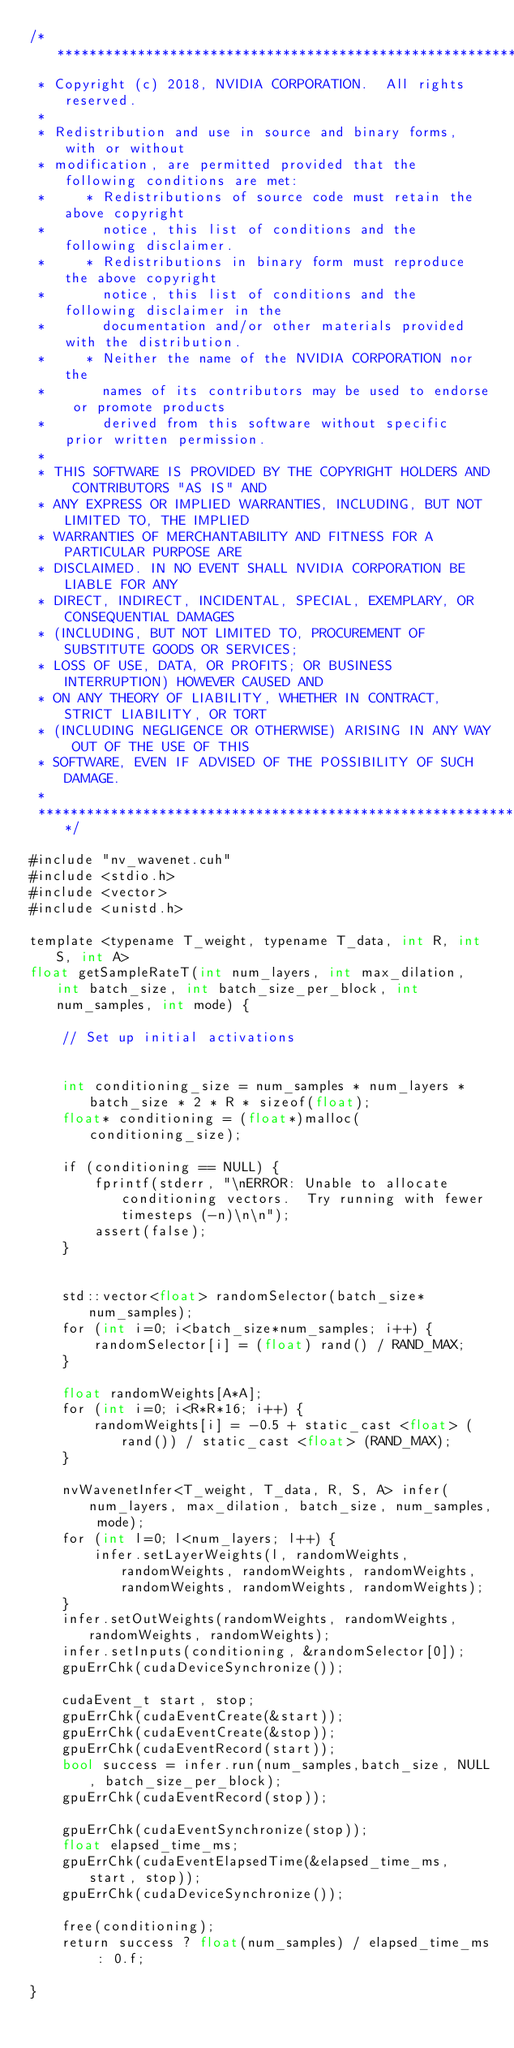<code> <loc_0><loc_0><loc_500><loc_500><_Cuda_>/******************************************************************************
 * Copyright (c) 2018, NVIDIA CORPORATION.  All rights reserved.
 *
 * Redistribution and use in source and binary forms, with or without
 * modification, are permitted provided that the following conditions are met:
 *     * Redistributions of source code must retain the above copyright
 *       notice, this list of conditions and the following disclaimer.
 *     * Redistributions in binary form must reproduce the above copyright
 *       notice, this list of conditions and the following disclaimer in the
 *       documentation and/or other materials provided with the distribution.
 *     * Neither the name of the NVIDIA CORPORATION nor the
 *       names of its contributors may be used to endorse or promote products
 *       derived from this software without specific prior written permission.
 *
 * THIS SOFTWARE IS PROVIDED BY THE COPYRIGHT HOLDERS AND CONTRIBUTORS "AS IS" AND
 * ANY EXPRESS OR IMPLIED WARRANTIES, INCLUDING, BUT NOT LIMITED TO, THE IMPLIED
 * WARRANTIES OF MERCHANTABILITY AND FITNESS FOR A PARTICULAR PURPOSE ARE
 * DISCLAIMED. IN NO EVENT SHALL NVIDIA CORPORATION BE LIABLE FOR ANY
 * DIRECT, INDIRECT, INCIDENTAL, SPECIAL, EXEMPLARY, OR CONSEQUENTIAL DAMAGES
 * (INCLUDING, BUT NOT LIMITED TO, PROCUREMENT OF SUBSTITUTE GOODS OR SERVICES;
 * LOSS OF USE, DATA, OR PROFITS; OR BUSINESS INTERRUPTION) HOWEVER CAUSED AND
 * ON ANY THEORY OF LIABILITY, WHETHER IN CONTRACT, STRICT LIABILITY, OR TORT
 * (INCLUDING NEGLIGENCE OR OTHERWISE) ARISING IN ANY WAY OUT OF THE USE OF THIS
 * SOFTWARE, EVEN IF ADVISED OF THE POSSIBILITY OF SUCH DAMAGE.
 *
 ******************************************************************************/

#include "nv_wavenet.cuh"
#include <stdio.h>
#include <vector>
#include <unistd.h>

template <typename T_weight, typename T_data, int R, int S, int A>
float getSampleRateT(int num_layers, int max_dilation, int batch_size, int batch_size_per_block, int num_samples, int mode) {

    // Set up initial activations


    int conditioning_size = num_samples * num_layers * batch_size * 2 * R * sizeof(float);
    float* conditioning = (float*)malloc(conditioning_size);

    if (conditioning == NULL) {
        fprintf(stderr, "\nERROR: Unable to allocate conditioning vectors.  Try running with fewer timesteps (-n)\n\n");        
        assert(false);
    }


    std::vector<float> randomSelector(batch_size*num_samples);
    for (int i=0; i<batch_size*num_samples; i++) {
        randomSelector[i] = (float) rand() / RAND_MAX;
    }

    float randomWeights[A*A];
    for (int i=0; i<R*R*16; i++) {
        randomWeights[i] = -0.5 + static_cast <float> (rand()) / static_cast <float> (RAND_MAX); 
    }

    nvWavenetInfer<T_weight, T_data, R, S, A> infer(num_layers, max_dilation, batch_size, num_samples, mode);
    for (int l=0; l<num_layers; l++) {
        infer.setLayerWeights(l, randomWeights, randomWeights, randomWeights, randomWeights, randomWeights, randomWeights, randomWeights);
    }
    infer.setOutWeights(randomWeights, randomWeights, randomWeights, randomWeights);
    infer.setInputs(conditioning, &randomSelector[0]); 
    gpuErrChk(cudaDeviceSynchronize());

    cudaEvent_t start, stop;
    gpuErrChk(cudaEventCreate(&start));
    gpuErrChk(cudaEventCreate(&stop));
    gpuErrChk(cudaEventRecord(start));
    bool success = infer.run(num_samples,batch_size, NULL, batch_size_per_block);
    gpuErrChk(cudaEventRecord(stop));

    gpuErrChk(cudaEventSynchronize(stop));
    float elapsed_time_ms;
    gpuErrChk(cudaEventElapsedTime(&elapsed_time_ms, start, stop));
    gpuErrChk(cudaDeviceSynchronize());

    free(conditioning);
    return success ? float(num_samples) / elapsed_time_ms : 0.f;

}
</code> 